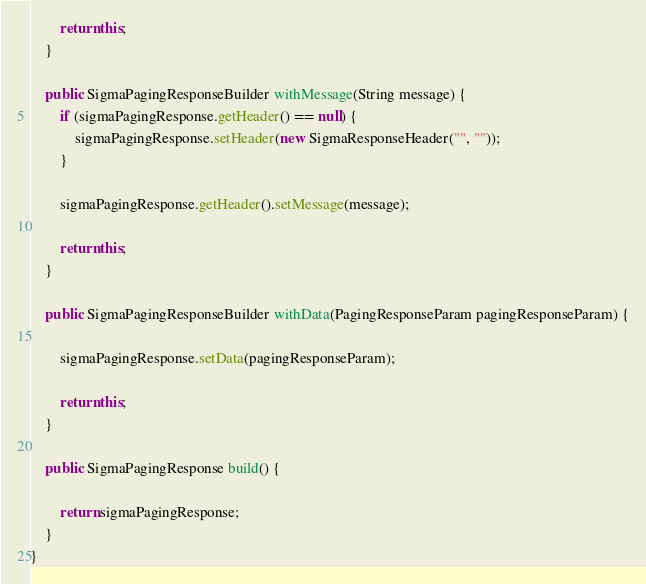Convert code to text. <code><loc_0><loc_0><loc_500><loc_500><_Java_>
        return this;
    }

    public SigmaPagingResponseBuilder withMessage(String message) {
        if (sigmaPagingResponse.getHeader() == null) {
            sigmaPagingResponse.setHeader(new SigmaResponseHeader("", ""));
        }

        sigmaPagingResponse.getHeader().setMessage(message);

        return this;
    }

    public SigmaPagingResponseBuilder withData(PagingResponseParam pagingResponseParam) {

        sigmaPagingResponse.setData(pagingResponseParam);

        return this;
    }

    public SigmaPagingResponse build() {

        return sigmaPagingResponse;
    }
}
</code> 